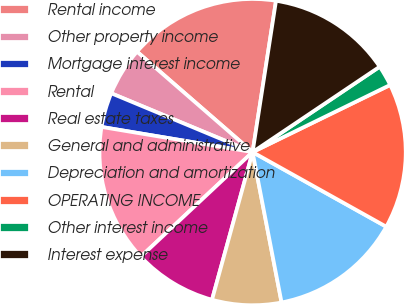<chart> <loc_0><loc_0><loc_500><loc_500><pie_chart><fcel>Rental income<fcel>Other property income<fcel>Mortgage interest income<fcel>Rental<fcel>Real estate taxes<fcel>General and administrative<fcel>Depreciation and amortization<fcel>OPERATING INCOME<fcel>Other interest income<fcel>Interest expense<nl><fcel>16.06%<fcel>5.11%<fcel>3.65%<fcel>14.6%<fcel>8.76%<fcel>7.3%<fcel>13.87%<fcel>15.33%<fcel>2.19%<fcel>13.14%<nl></chart> 